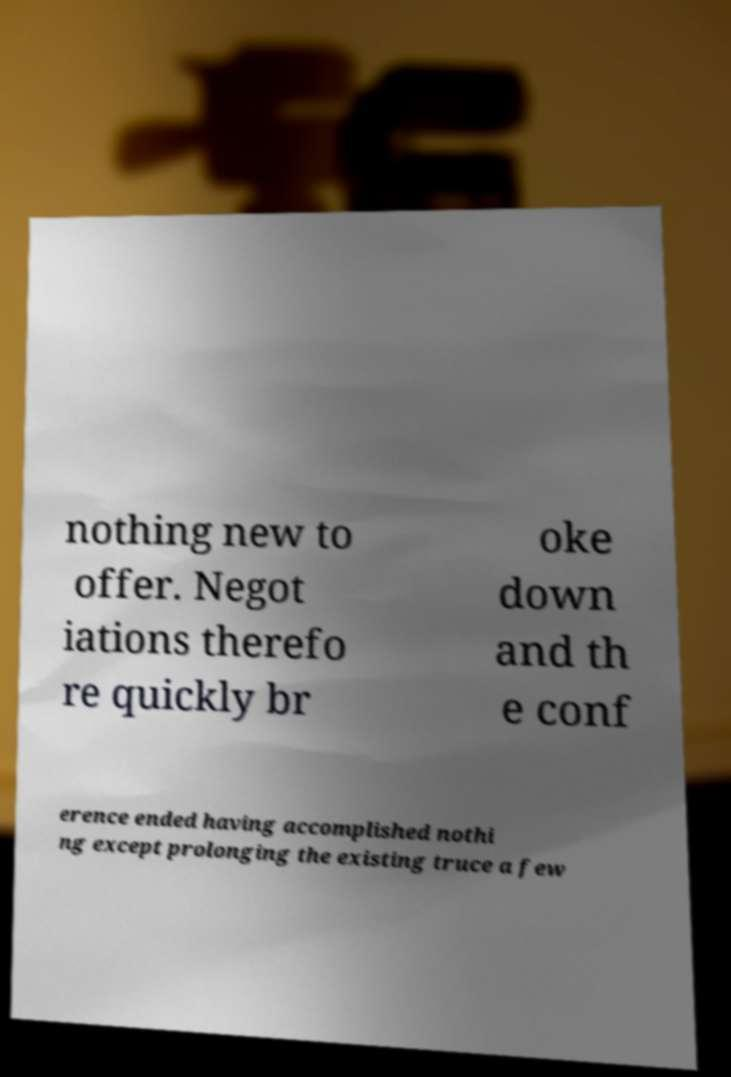Please identify and transcribe the text found in this image. nothing new to offer. Negot iations therefo re quickly br oke down and th e conf erence ended having accomplished nothi ng except prolonging the existing truce a few 